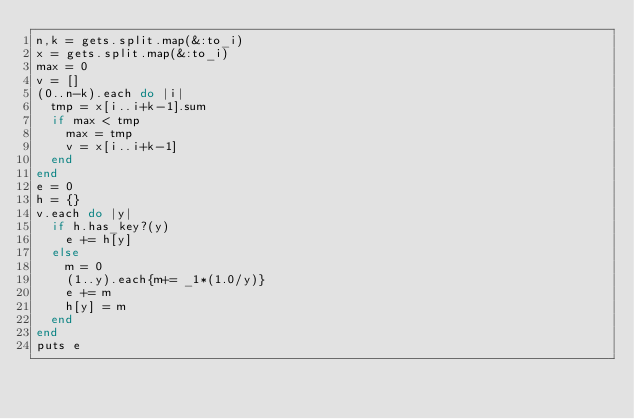<code> <loc_0><loc_0><loc_500><loc_500><_Ruby_>n,k = gets.split.map(&:to_i)
x = gets.split.map(&:to_i)
max = 0
v = []
(0..n-k).each do |i|
  tmp = x[i..i+k-1].sum
  if max < tmp
    max = tmp
    v = x[i..i+k-1]
  end
end
e = 0
h = {}
v.each do |y|
  if h.has_key?(y)
    e += h[y]
  else
    m = 0
    (1..y).each{m+= _1*(1.0/y)}
    e += m
    h[y] = m
  end
end
puts e</code> 